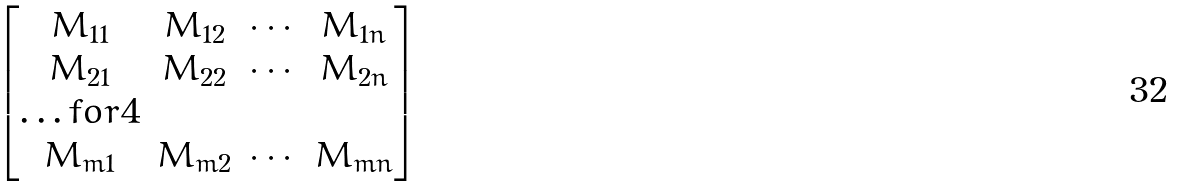<formula> <loc_0><loc_0><loc_500><loc_500>\begin{bmatrix} M _ { 1 1 } & M _ { 1 2 } & \cdots & M _ { 1 n } \\ M _ { 2 1 } & M _ { 2 2 } & \cdots & M _ { 2 n } \\ \hdots f o r { 4 } \\ M _ { m 1 } & M _ { m 2 } & \cdots & M _ { m n } \end{bmatrix}</formula> 